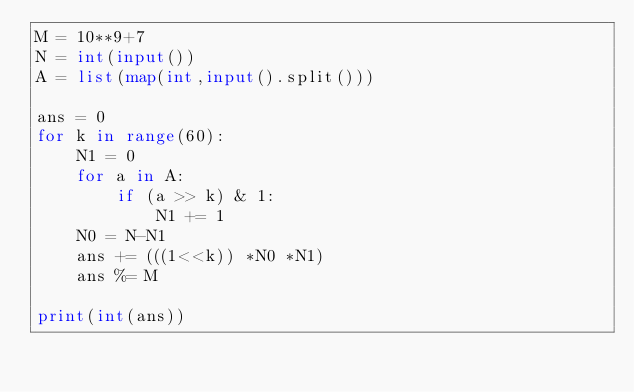<code> <loc_0><loc_0><loc_500><loc_500><_Python_>M = 10**9+7
N = int(input())
A = list(map(int,input().split()))

ans = 0
for k in range(60):
    N1 = 0
    for a in A:
        if (a >> k) & 1:
            N1 += 1
    N0 = N-N1
    ans += (((1<<k)) *N0 *N1)
    ans %= M    

print(int(ans))</code> 